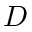Convert formula to latex. <formula><loc_0><loc_0><loc_500><loc_500>D</formula> 